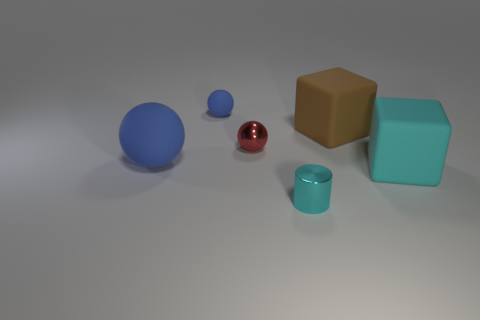Do the big ball and the small rubber object have the same color?
Your response must be concise. Yes. There is a block that is the same color as the cylinder; what material is it?
Make the answer very short. Rubber. Do the cylinder and the brown rubber thing have the same size?
Your response must be concise. No. What is the size of the ball on the right side of the matte ball that is behind the big blue matte object?
Offer a terse response. Small. Does the big rubber ball have the same color as the rubber ball that is behind the big brown object?
Offer a terse response. Yes. Is there a blue thing that has the same size as the cyan cylinder?
Offer a terse response. Yes. There is a matte ball behind the large brown thing; what size is it?
Your response must be concise. Small. There is a blue object that is left of the tiny blue matte sphere; is there a small red metal ball left of it?
Provide a short and direct response. No. What number of other objects are the same shape as the big blue object?
Keep it short and to the point. 2. Do the red object and the cyan metallic thing have the same shape?
Ensure brevity in your answer.  No. 